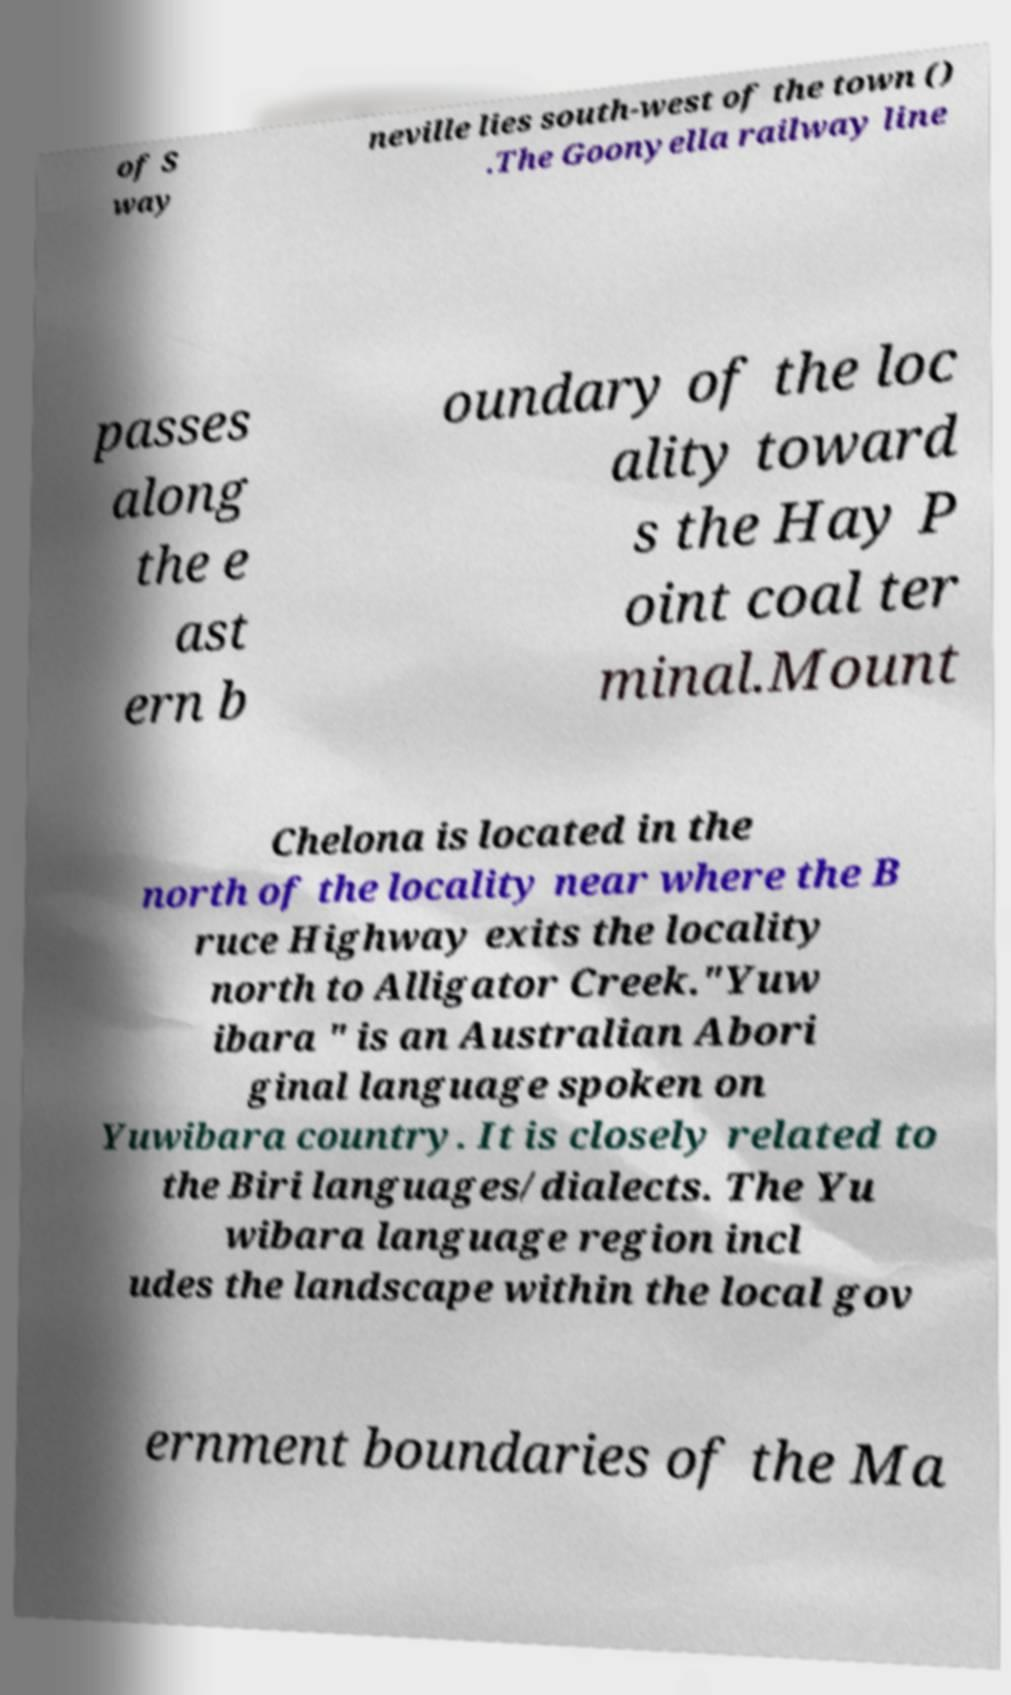Please identify and transcribe the text found in this image. of S way neville lies south-west of the town () .The Goonyella railway line passes along the e ast ern b oundary of the loc ality toward s the Hay P oint coal ter minal.Mount Chelona is located in the north of the locality near where the B ruce Highway exits the locality north to Alligator Creek."Yuw ibara " is an Australian Abori ginal language spoken on Yuwibara country. It is closely related to the Biri languages/dialects. The Yu wibara language region incl udes the landscape within the local gov ernment boundaries of the Ma 